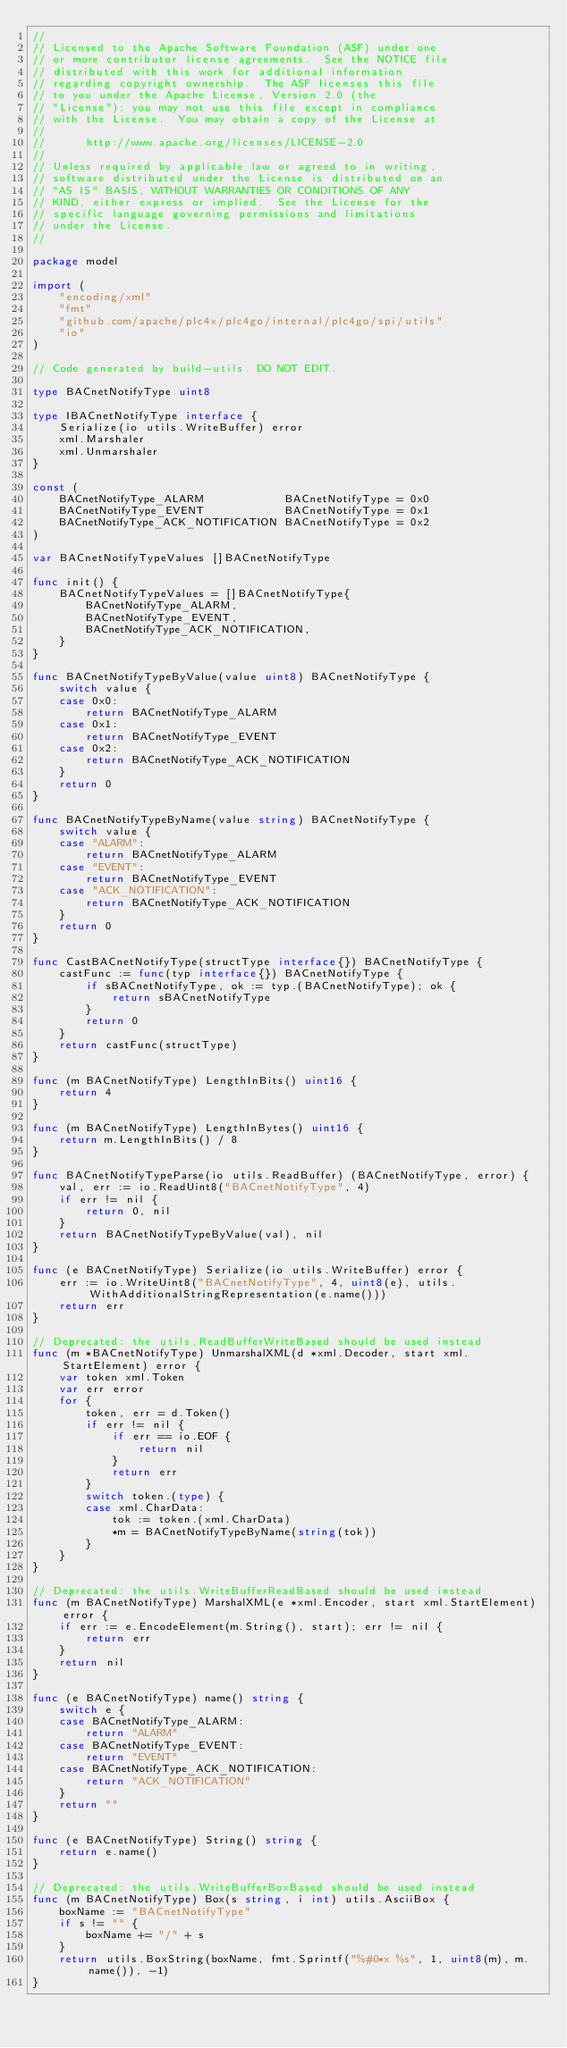Convert code to text. <code><loc_0><loc_0><loc_500><loc_500><_Go_>//
// Licensed to the Apache Software Foundation (ASF) under one
// or more contributor license agreements.  See the NOTICE file
// distributed with this work for additional information
// regarding copyright ownership.  The ASF licenses this file
// to you under the Apache License, Version 2.0 (the
// "License"); you may not use this file except in compliance
// with the License.  You may obtain a copy of the License at
//
//      http://www.apache.org/licenses/LICENSE-2.0
//
// Unless required by applicable law or agreed to in writing,
// software distributed under the License is distributed on an
// "AS IS" BASIS, WITHOUT WARRANTIES OR CONDITIONS OF ANY
// KIND, either express or implied.  See the License for the
// specific language governing permissions and limitations
// under the License.
//

package model

import (
	"encoding/xml"
	"fmt"
	"github.com/apache/plc4x/plc4go/internal/plc4go/spi/utils"
	"io"
)

// Code generated by build-utils. DO NOT EDIT.

type BACnetNotifyType uint8

type IBACnetNotifyType interface {
	Serialize(io utils.WriteBuffer) error
	xml.Marshaler
	xml.Unmarshaler
}

const (
	BACnetNotifyType_ALARM            BACnetNotifyType = 0x0
	BACnetNotifyType_EVENT            BACnetNotifyType = 0x1
	BACnetNotifyType_ACK_NOTIFICATION BACnetNotifyType = 0x2
)

var BACnetNotifyTypeValues []BACnetNotifyType

func init() {
	BACnetNotifyTypeValues = []BACnetNotifyType{
		BACnetNotifyType_ALARM,
		BACnetNotifyType_EVENT,
		BACnetNotifyType_ACK_NOTIFICATION,
	}
}

func BACnetNotifyTypeByValue(value uint8) BACnetNotifyType {
	switch value {
	case 0x0:
		return BACnetNotifyType_ALARM
	case 0x1:
		return BACnetNotifyType_EVENT
	case 0x2:
		return BACnetNotifyType_ACK_NOTIFICATION
	}
	return 0
}

func BACnetNotifyTypeByName(value string) BACnetNotifyType {
	switch value {
	case "ALARM":
		return BACnetNotifyType_ALARM
	case "EVENT":
		return BACnetNotifyType_EVENT
	case "ACK_NOTIFICATION":
		return BACnetNotifyType_ACK_NOTIFICATION
	}
	return 0
}

func CastBACnetNotifyType(structType interface{}) BACnetNotifyType {
	castFunc := func(typ interface{}) BACnetNotifyType {
		if sBACnetNotifyType, ok := typ.(BACnetNotifyType); ok {
			return sBACnetNotifyType
		}
		return 0
	}
	return castFunc(structType)
}

func (m BACnetNotifyType) LengthInBits() uint16 {
	return 4
}

func (m BACnetNotifyType) LengthInBytes() uint16 {
	return m.LengthInBits() / 8
}

func BACnetNotifyTypeParse(io utils.ReadBuffer) (BACnetNotifyType, error) {
	val, err := io.ReadUint8("BACnetNotifyType", 4)
	if err != nil {
		return 0, nil
	}
	return BACnetNotifyTypeByValue(val), nil
}

func (e BACnetNotifyType) Serialize(io utils.WriteBuffer) error {
	err := io.WriteUint8("BACnetNotifyType", 4, uint8(e), utils.WithAdditionalStringRepresentation(e.name()))
	return err
}

// Deprecated: the utils.ReadBufferWriteBased should be used instead
func (m *BACnetNotifyType) UnmarshalXML(d *xml.Decoder, start xml.StartElement) error {
	var token xml.Token
	var err error
	for {
		token, err = d.Token()
		if err != nil {
			if err == io.EOF {
				return nil
			}
			return err
		}
		switch token.(type) {
		case xml.CharData:
			tok := token.(xml.CharData)
			*m = BACnetNotifyTypeByName(string(tok))
		}
	}
}

// Deprecated: the utils.WriteBufferReadBased should be used instead
func (m BACnetNotifyType) MarshalXML(e *xml.Encoder, start xml.StartElement) error {
	if err := e.EncodeElement(m.String(), start); err != nil {
		return err
	}
	return nil
}

func (e BACnetNotifyType) name() string {
	switch e {
	case BACnetNotifyType_ALARM:
		return "ALARM"
	case BACnetNotifyType_EVENT:
		return "EVENT"
	case BACnetNotifyType_ACK_NOTIFICATION:
		return "ACK_NOTIFICATION"
	}
	return ""
}

func (e BACnetNotifyType) String() string {
	return e.name()
}

// Deprecated: the utils.WriteBufferBoxBased should be used instead
func (m BACnetNotifyType) Box(s string, i int) utils.AsciiBox {
	boxName := "BACnetNotifyType"
	if s != "" {
		boxName += "/" + s
	}
	return utils.BoxString(boxName, fmt.Sprintf("%#0*x %s", 1, uint8(m), m.name()), -1)
}
</code> 